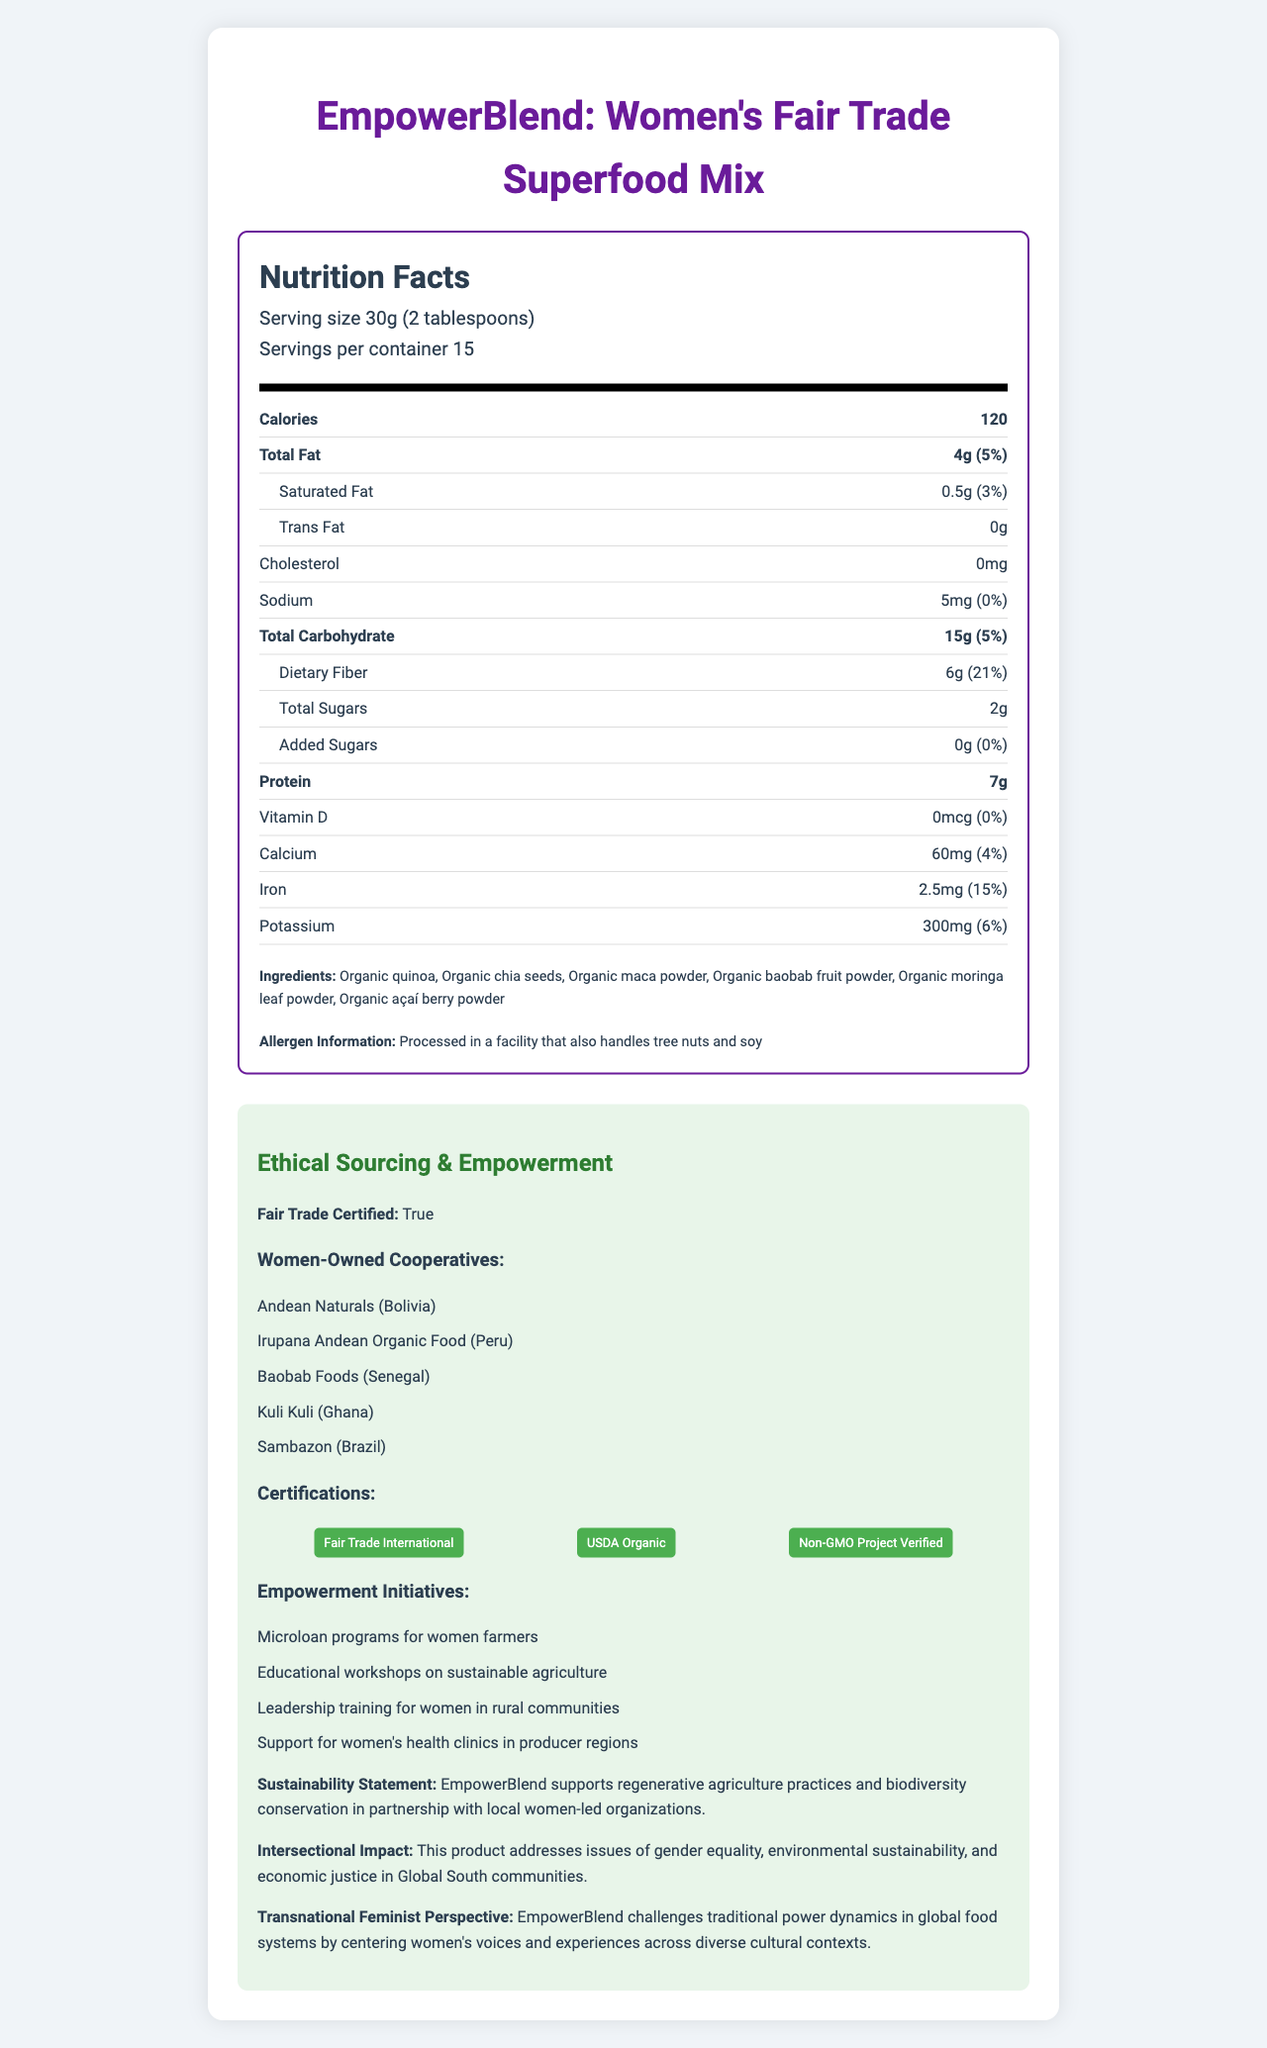what is the serving size for EmpowerBlend? The document lists the serving size as "30g (2 tablespoons)" under the nutrition facts label.
Answer: 30g (2 tablespoons) how many calories are in one serving of the EmpowerBlend? The nutrition facts label specifies that each serving contains 120 calories.
Answer: 120 what is the total fat content in one serving? The total fat content per serving is listed as 4g, which is 5% of the daily value.
Answer: 4g (5%) how much iron is in each serving, and what percentage of the daily value does this represent? The document specifies that each serving contains 2.5mg of iron, which is 15% of the daily value.
Answer: 2.5mg (15%) what ingredients are listed in the EmpowerBlend? The ingredients are listed as organic quinoa, organic chia seeds, organic maca powder, organic baobab fruit powder, organic moringa leaf powder, and organic açaí berry powder.
Answer: Organic quinoa, Organic chia seeds, Organic maca powder, Organic baobab fruit powder, Organic moringa leaf powder, Organic açaí berry powder which certifications does the EmpowerBlend have? A. USDA Organic B. Fair Trade International C. Non-GMO Project Verified D. All of the above The document states that the product is certified by Fair Trade International, USDA Organic, and Non-GMO Project Verified.
Answer: D which of the following cooperatives is NOT involved in producing EmpowerBlend? A. Andean Naturals B. Irupana Andean Organic Food C. Baobab Foods D. Amazon Origins The list of women-owned cooperatives does not include Amazon Origins.
Answer: D is the EmpowerBlend processed in a facility that handles tree nuts and soy? The document indicates that the blend is processed in a facility that also handles tree nuts and soy.
Answer: Yes does EmpowerBlend include any added sugars? The nutrition facts label shows that the product has 0g of added sugars and 0% of the daily value.
Answer: No describe the main idea of the document. The main purpose of the document is to present comprehensive nutritional information as well as highlight the ethical and empowerment-related aspects of the product, such as fair trade certification, involvement of women-owned cooperatives, and commitment to sustainability.
Answer: The document provides detailed information about the nutritional content of a superfood blend called EmpowerBlend, emphasizing ethical sourcing, fair trade certification, and women's empowerment initiatives. It highlights the product's nutritional values, ingredients, allergen information, and various certifications while also detailing the empowerment and sustainability efforts associated with the product. how many microloan programs are mentioned as empowerment initiatives for women farmers? The document lists "Microloan programs for women farmers" as one of the empowerment initiatives.
Answer: Microloan programs for women farmers which certification is given for non-GMO compliance? The certification for non-GMO compliance is listed as "Non-GMO Project Verified."
Answer: Non-GMO Project Verified did EmpowerBlend contain any açaí berry powder? The document lists "organic açaí berry powder" in the ingredients section.
Answer: Yes how many servings are in one container of EmpowerBlend? The document states that there are 15 servings per container.
Answer: 15 from which country does Sambazon cooperative come? A. Peru B. Bolivia C. Brazil D. Ghana According to the document, the Sambazon cooperative is from Brazil.
Answer: C what is the daily value percentage of dietary fiber in one serving of EmpowerBlend? The nutritional label states that one serving provides 6g of dietary fiber, which is 21% of the daily value.
Answer: 21% how much Vitamin D is in one serving? The nutrition facts label states that there is 0mcg of Vitamin D in one serving of the product.
Answer: 0mcg which women's health initiatives are supported by the product? The document lists "Support for women's health clinics in producer regions" as one of the empowerment initiatives.
Answer: Support for women's health clinics in producer regions what challenges do women farmers face in participating in leadership training? The document describes that leadership training for women in rural communities is part of the empowerment initiatives but does not provide details on the challenges faced by women farmers in participating in these training programs.
Answer: Not enough information 